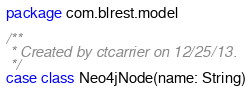Convert code to text. <code><loc_0><loc_0><loc_500><loc_500><_Scala_>package com.blrest.model

/**
 * Created by ctcarrier on 12/25/13.
 */
case class Neo4jNode(name: String)
</code> 